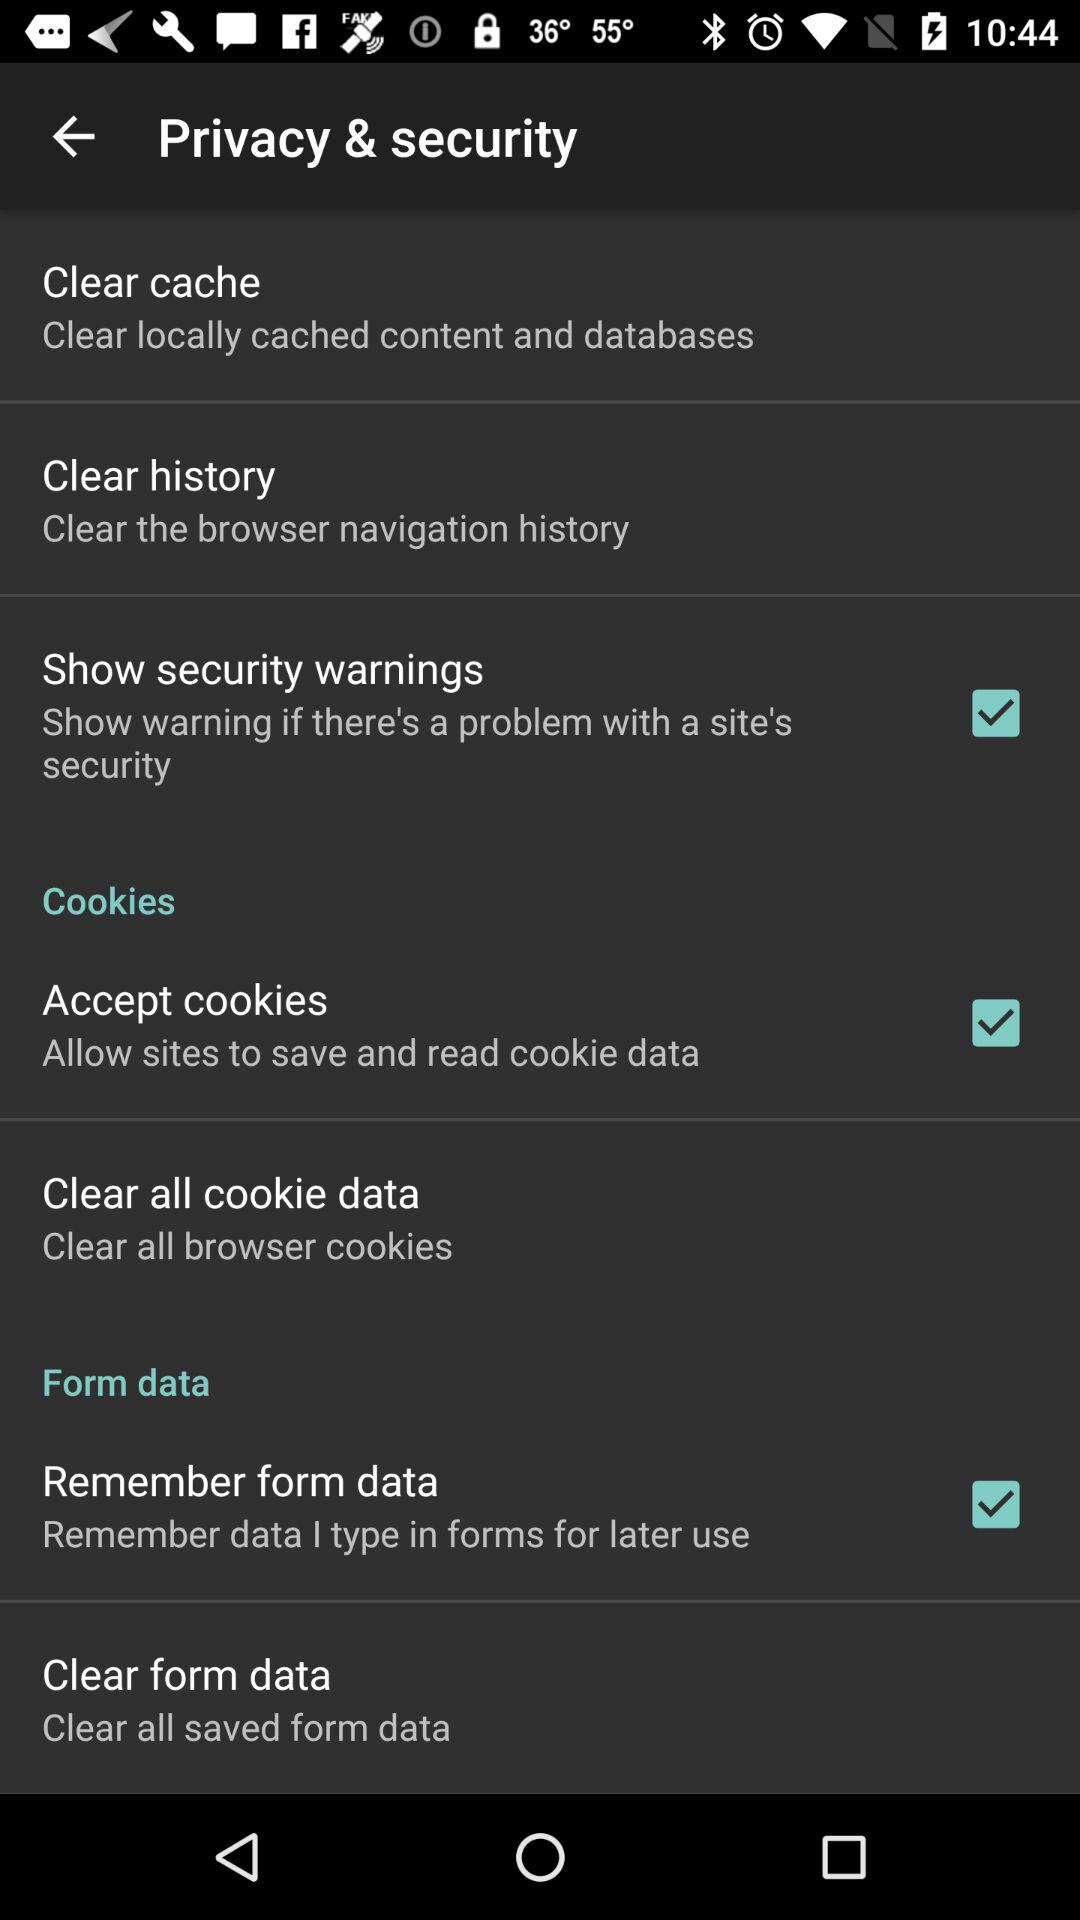What is the status of "Accept cookies"? The status is "on". 